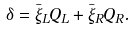Convert formula to latex. <formula><loc_0><loc_0><loc_500><loc_500>\delta = \bar { \xi } _ { L } Q _ { L } + \bar { \xi } _ { R } Q _ { R } .</formula> 